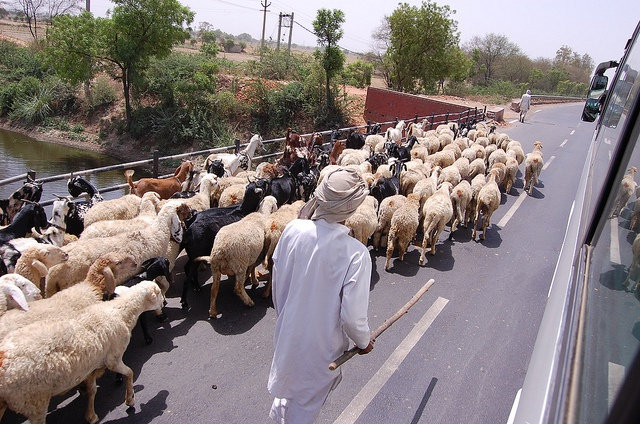Describe the objects in this image and their specific colors. I can see bus in lightgray, gray, darkgray, black, and lavender tones, people in lightgray, darkgray, and gray tones, sheep in lightgray, gray, and tan tones, sheep in lightgray, tan, and gray tones, and sheep in lightgray, maroon, gray, and tan tones in this image. 